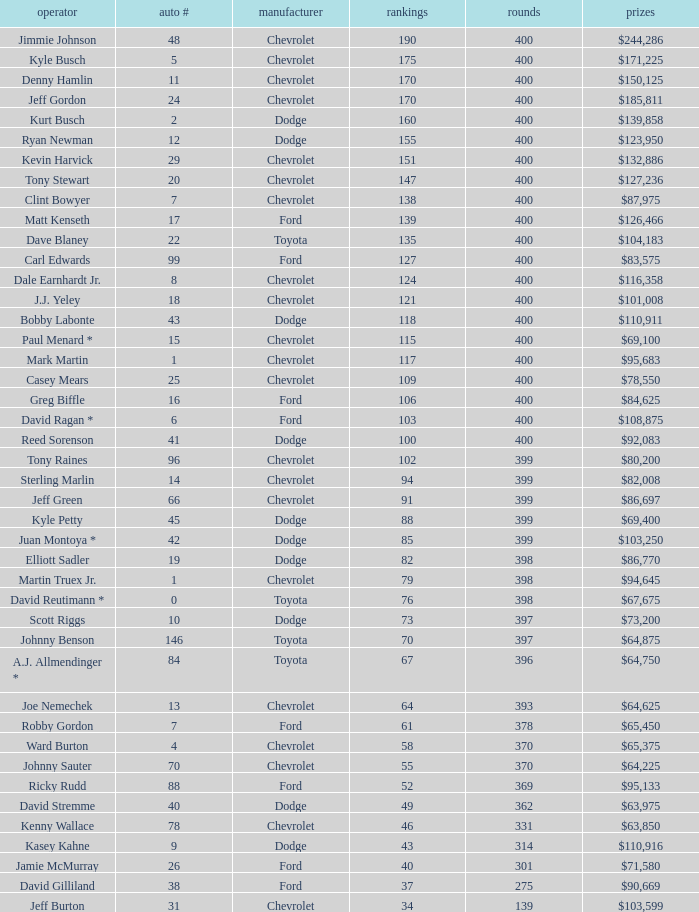What is the make of car 31? Chevrolet. 